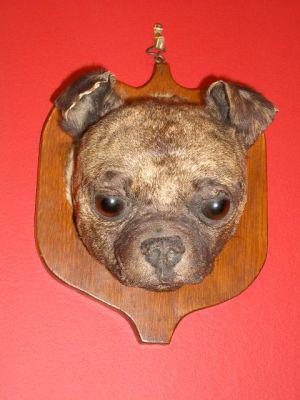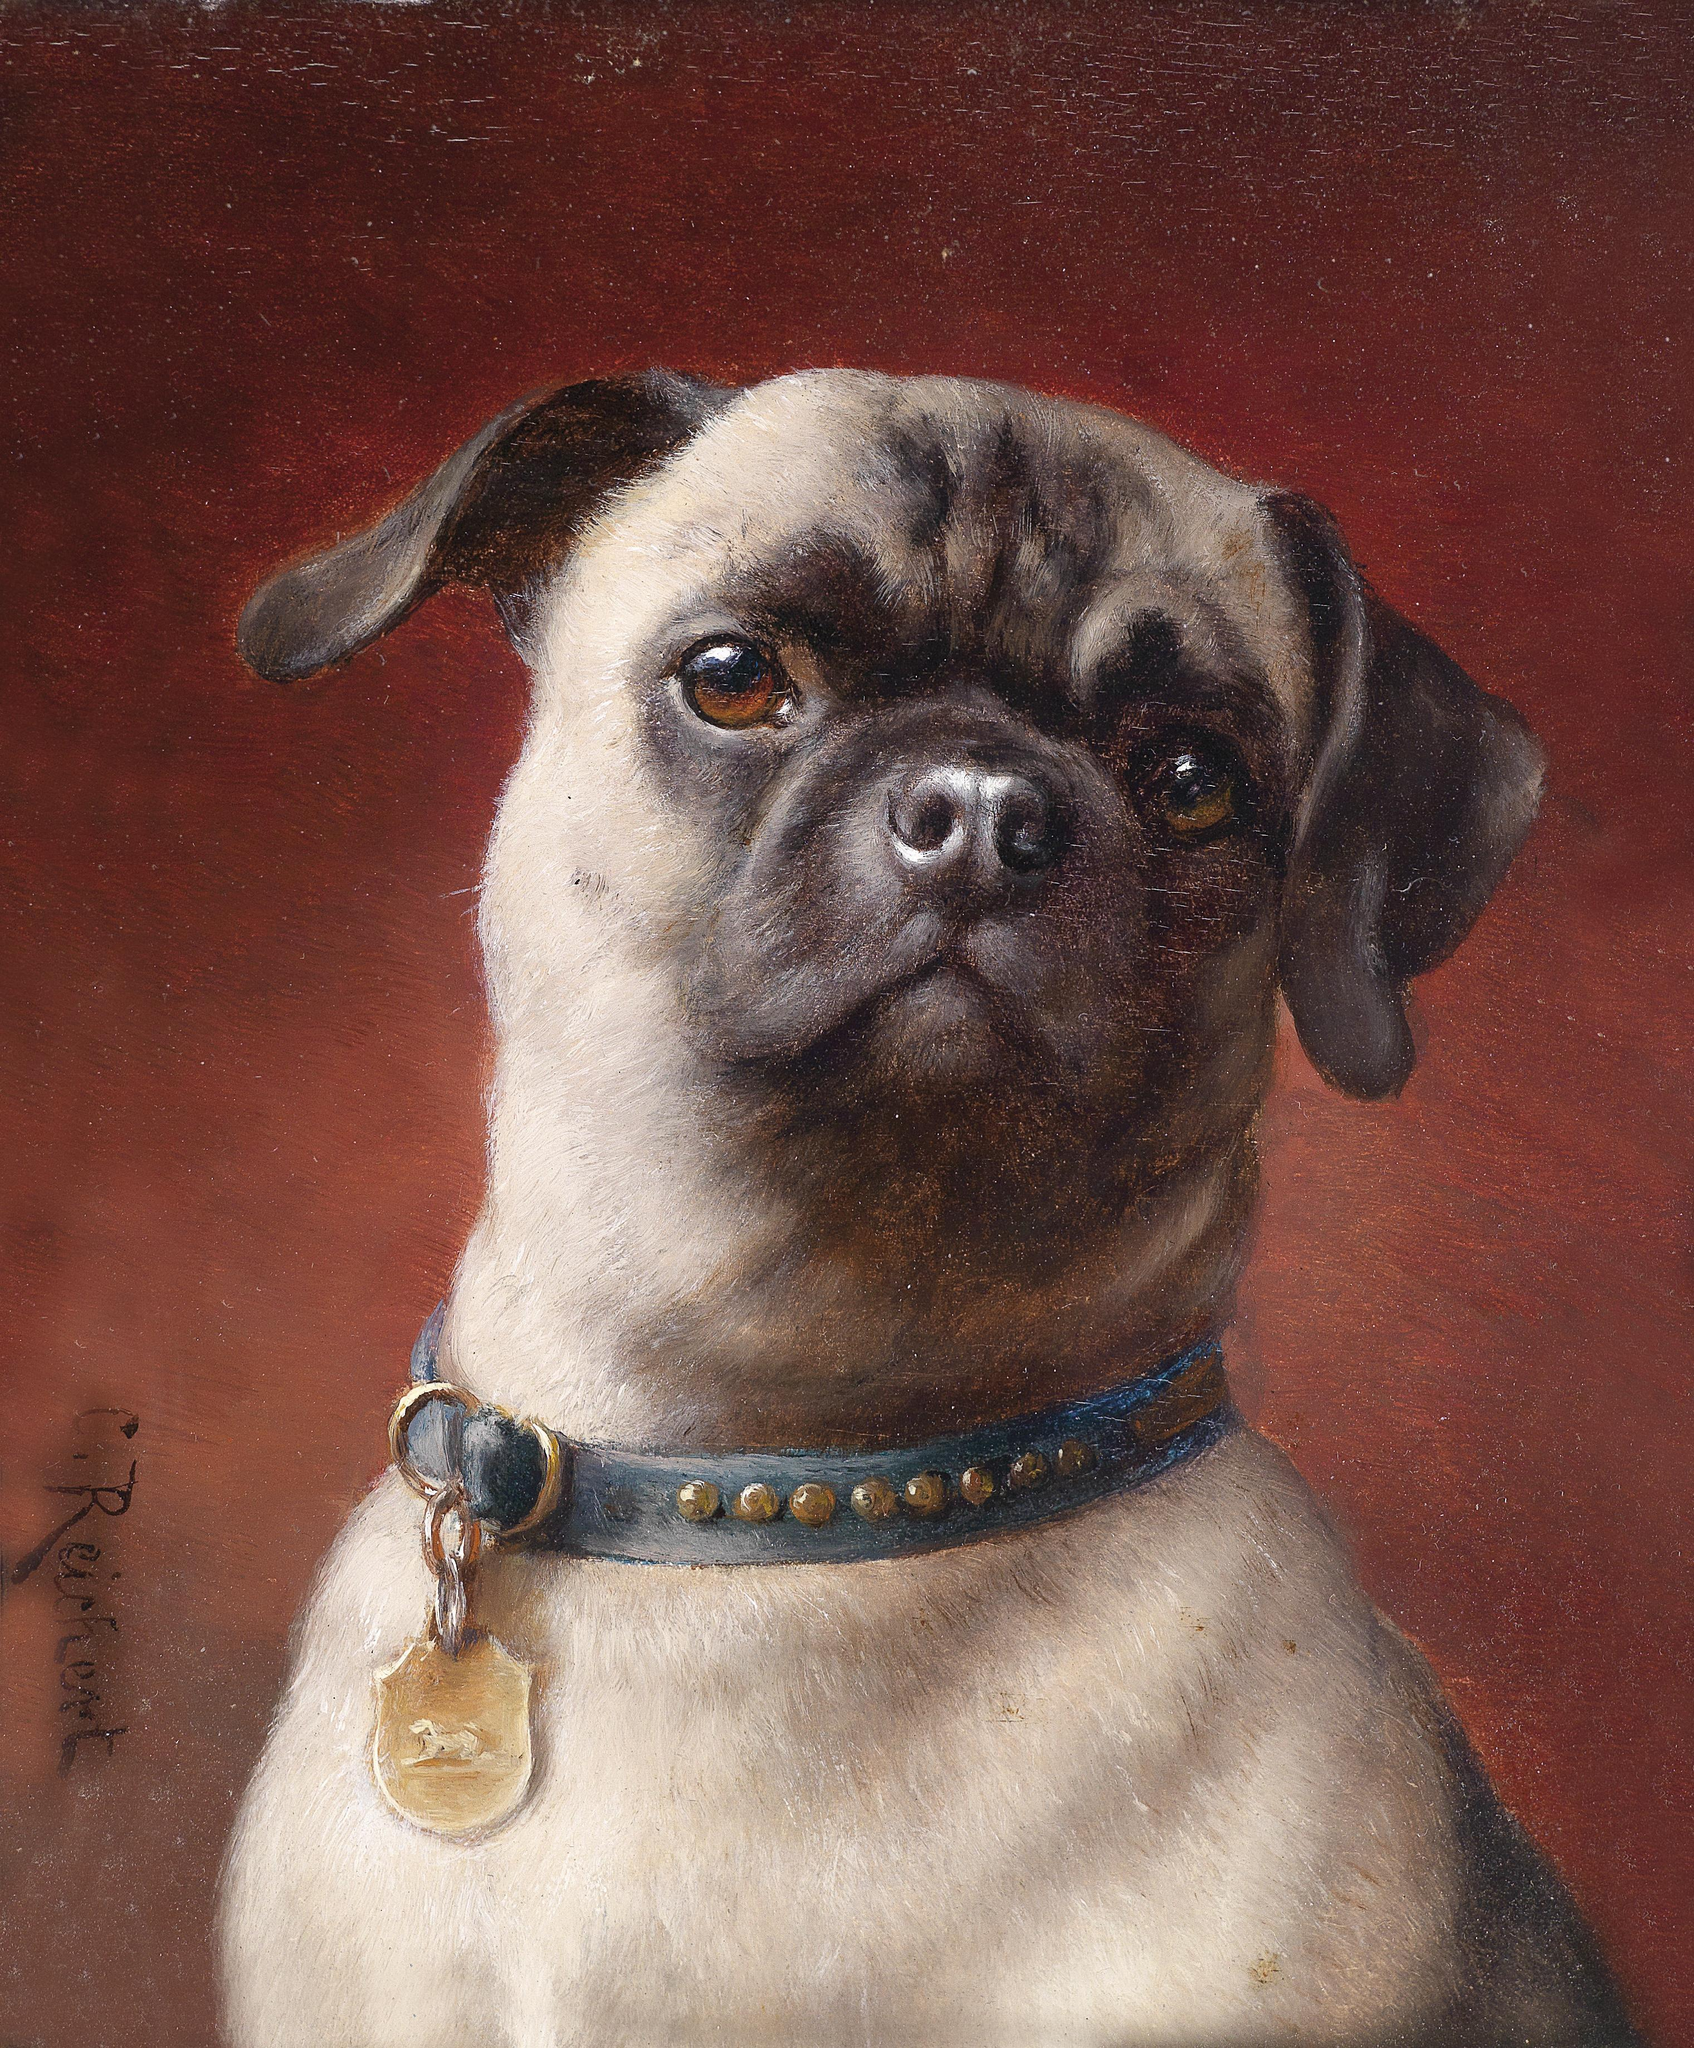The first image is the image on the left, the second image is the image on the right. Considering the images on both sides, is "One of the images features a taxidermy dog." valid? Answer yes or no. Yes. The first image is the image on the left, the second image is the image on the right. Evaluate the accuracy of this statement regarding the images: "The left image shows one live pug that is not wearing a costume, and the right image includes a flat-faced dog and a pig snout". Is it true? Answer yes or no. No. 